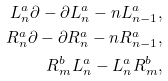<formula> <loc_0><loc_0><loc_500><loc_500>L _ { n } ^ { a } \partial - \partial L _ { n } ^ { a } - n L _ { n - 1 } ^ { a } , \\ R _ { n } ^ { a } \partial - \partial R _ { n } ^ { a } - n R _ { n - 1 } ^ { a } , \\ R _ { m } ^ { b } L _ { n } ^ { a } - L _ { n } ^ { a } R _ { m } ^ { b } ,</formula> 